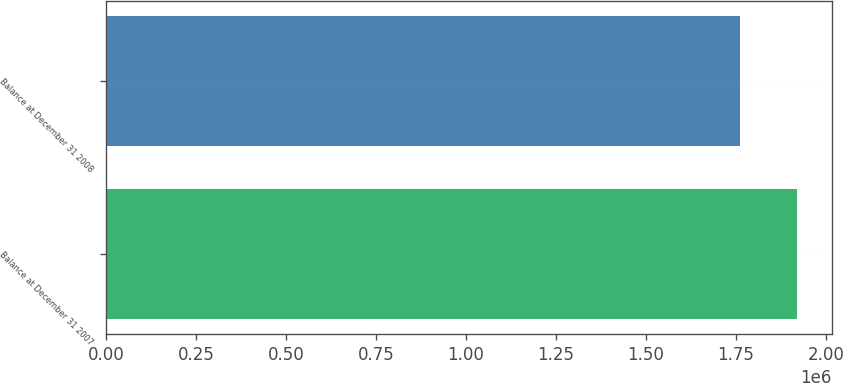Convert chart. <chart><loc_0><loc_0><loc_500><loc_500><bar_chart><fcel>Balance at December 31 2007<fcel>Balance at December 31 2008<nl><fcel>1.92053e+06<fcel>1.76228e+06<nl></chart> 